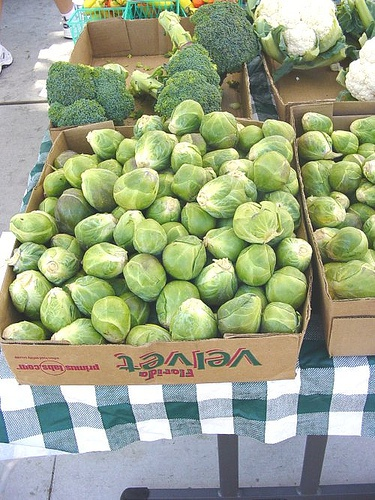Describe the objects in this image and their specific colors. I can see dining table in gray, white, darkgray, and lightblue tones, broccoli in gray, teal, darkgray, and olive tones, broccoli in gray, khaki, green, olive, and darkgray tones, broccoli in gray, green, lightgreen, darkgreen, and darkgray tones, and broccoli in gray, green, teal, darkgray, and olive tones in this image. 